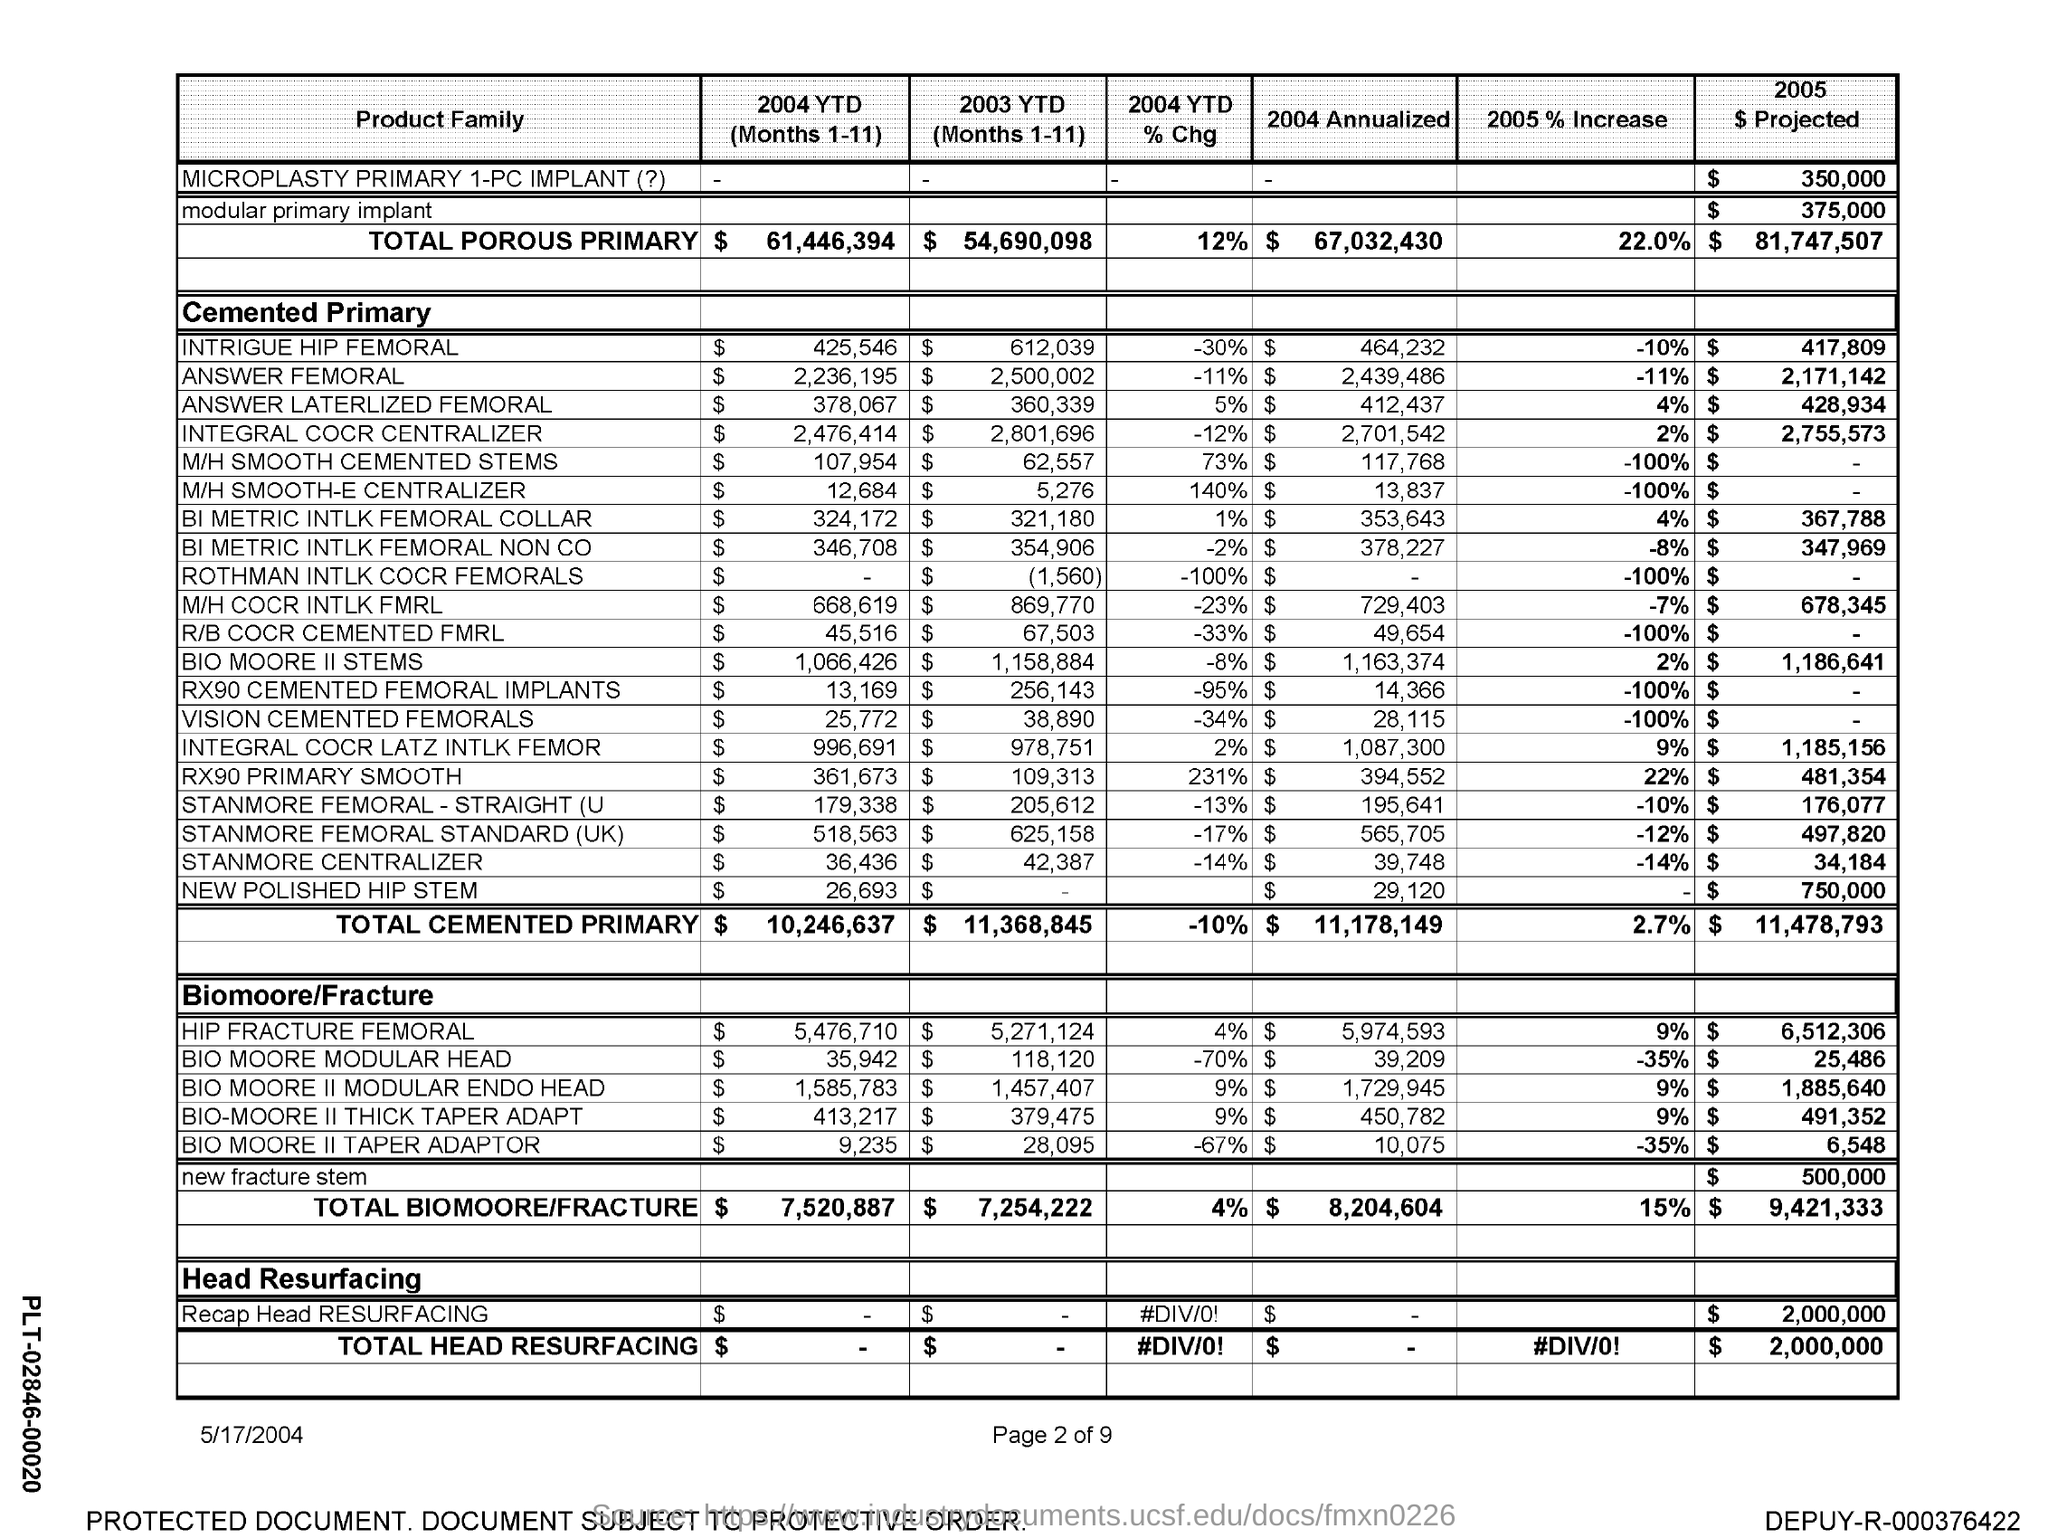Highlight a few significant elements in this photo. Total cemented primary production for the year-to-date (January through November) in 2004 was $10,246,637. The total cemented primary for the year 2004 has been annualized, resulting in an estimated amount of $11,178,149. The total cemented primary for the first 11 months of 2003 is 11,368,845. The total cemented primary was increased by 2005% in 2005, resulting in a total of 2.7%. The total cemented primary for 2004 year-to-date has decreased by 10% compared to the same period last year. 